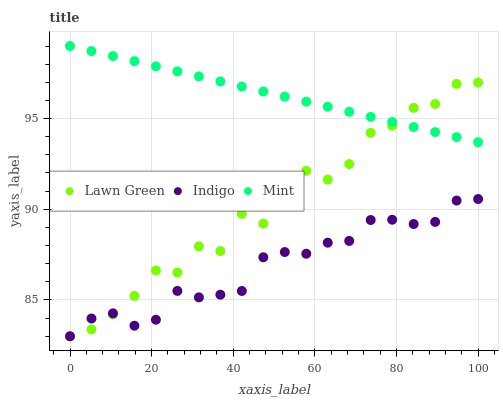Does Indigo have the minimum area under the curve?
Answer yes or no. Yes. Does Mint have the maximum area under the curve?
Answer yes or no. Yes. Does Mint have the minimum area under the curve?
Answer yes or no. No. Does Indigo have the maximum area under the curve?
Answer yes or no. No. Is Mint the smoothest?
Answer yes or no. Yes. Is Lawn Green the roughest?
Answer yes or no. Yes. Is Indigo the smoothest?
Answer yes or no. No. Is Indigo the roughest?
Answer yes or no. No. Does Lawn Green have the lowest value?
Answer yes or no. Yes. Does Mint have the lowest value?
Answer yes or no. No. Does Mint have the highest value?
Answer yes or no. Yes. Does Indigo have the highest value?
Answer yes or no. No. Is Indigo less than Mint?
Answer yes or no. Yes. Is Mint greater than Indigo?
Answer yes or no. Yes. Does Lawn Green intersect Indigo?
Answer yes or no. Yes. Is Lawn Green less than Indigo?
Answer yes or no. No. Is Lawn Green greater than Indigo?
Answer yes or no. No. Does Indigo intersect Mint?
Answer yes or no. No. 